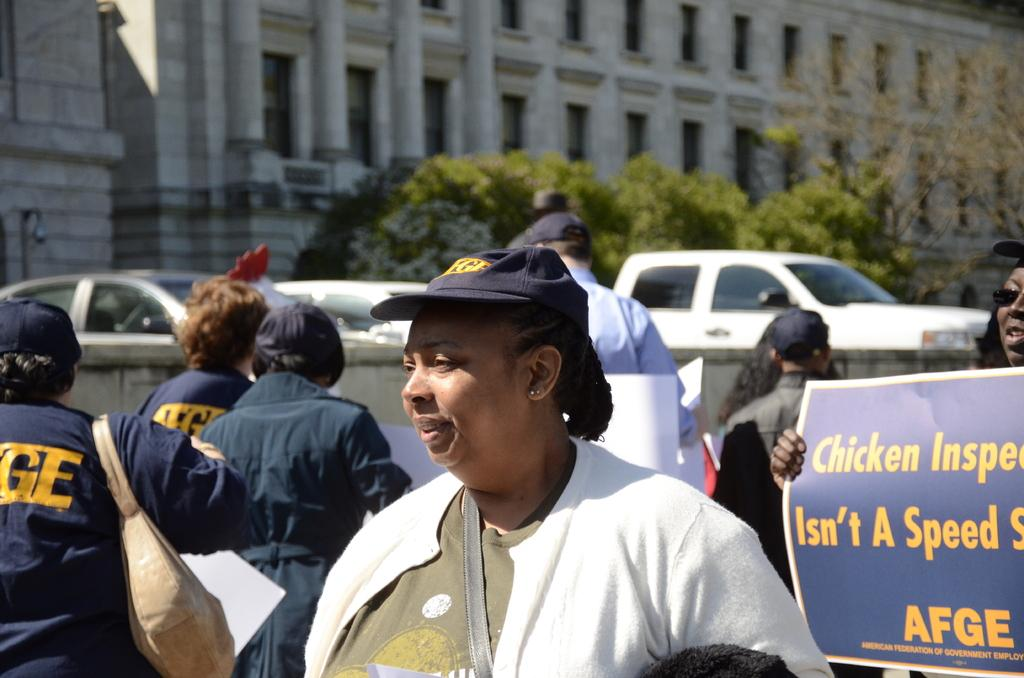How many people are in the group that is visible in the image? There is a group of people in the image, but the exact number is not specified. What are some people in the group wearing? Some people in the group are wearing caps. What are some people in the group holding? Some people in the group are holding placards. What can be seen in the background of the image? In the background of the image, there are cars, trees, and buildings. What type of field is visible in the image? There is no field visible in the image; it features a group of people, placards, and background elements such as cars, trees, and buildings. What industry is represented by the fifth person in the group? There is no mention of a fifth person in the group, nor any indication of an industry they might represent. 